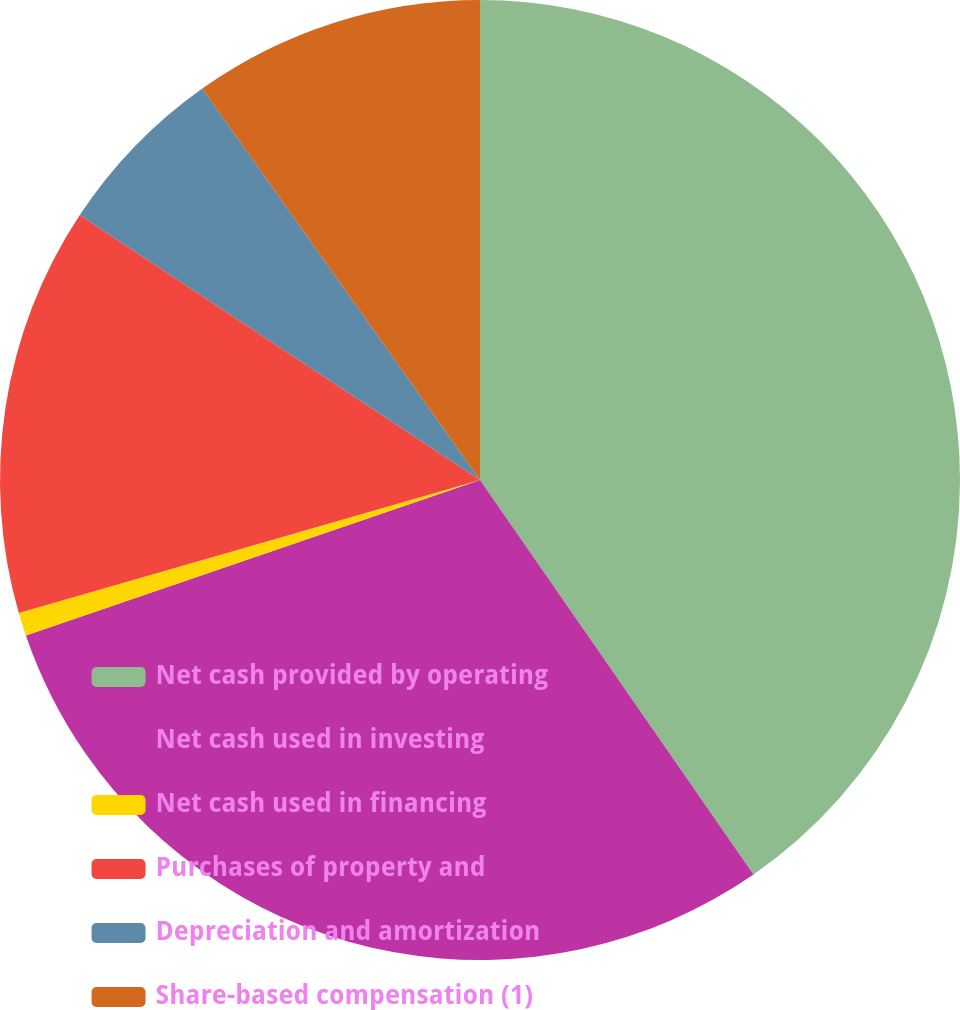<chart> <loc_0><loc_0><loc_500><loc_500><pie_chart><fcel>Net cash provided by operating<fcel>Net cash used in investing<fcel>Net cash used in financing<fcel>Purchases of property and<fcel>Depreciation and amortization<fcel>Share-based compensation (1)<nl><fcel>40.35%<fcel>29.4%<fcel>0.78%<fcel>13.78%<fcel>5.87%<fcel>9.82%<nl></chart> 